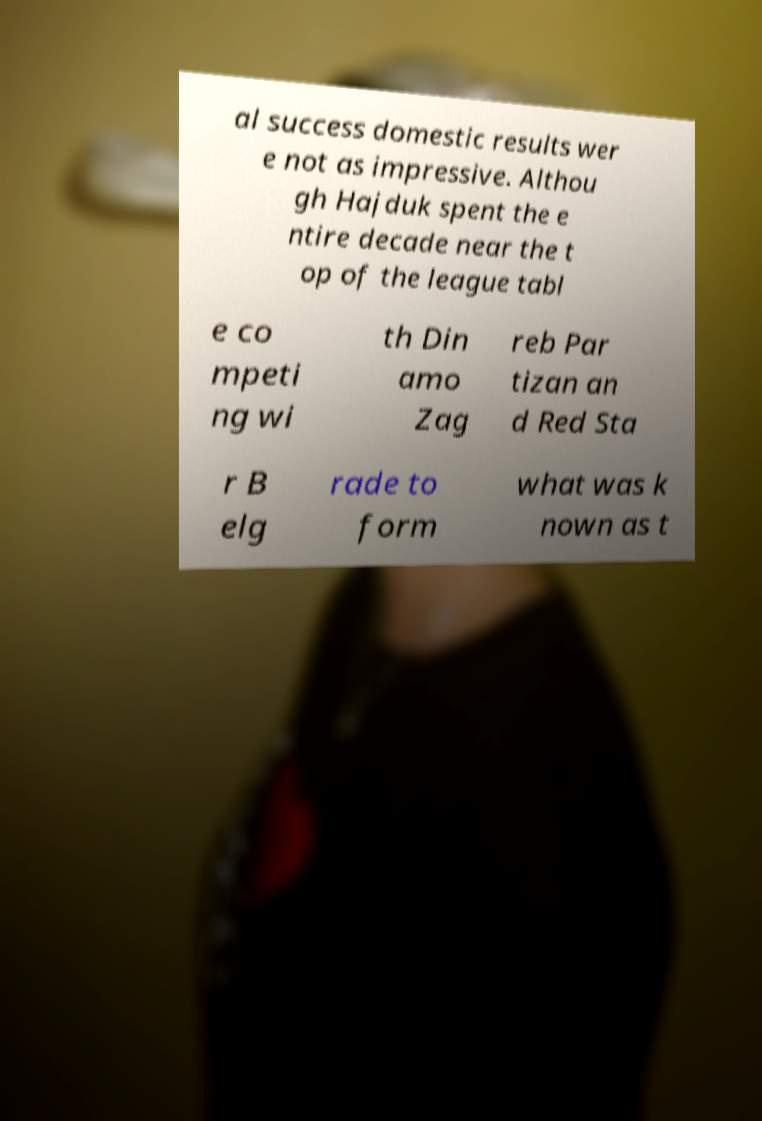Could you extract and type out the text from this image? al success domestic results wer e not as impressive. Althou gh Hajduk spent the e ntire decade near the t op of the league tabl e co mpeti ng wi th Din amo Zag reb Par tizan an d Red Sta r B elg rade to form what was k nown as t 